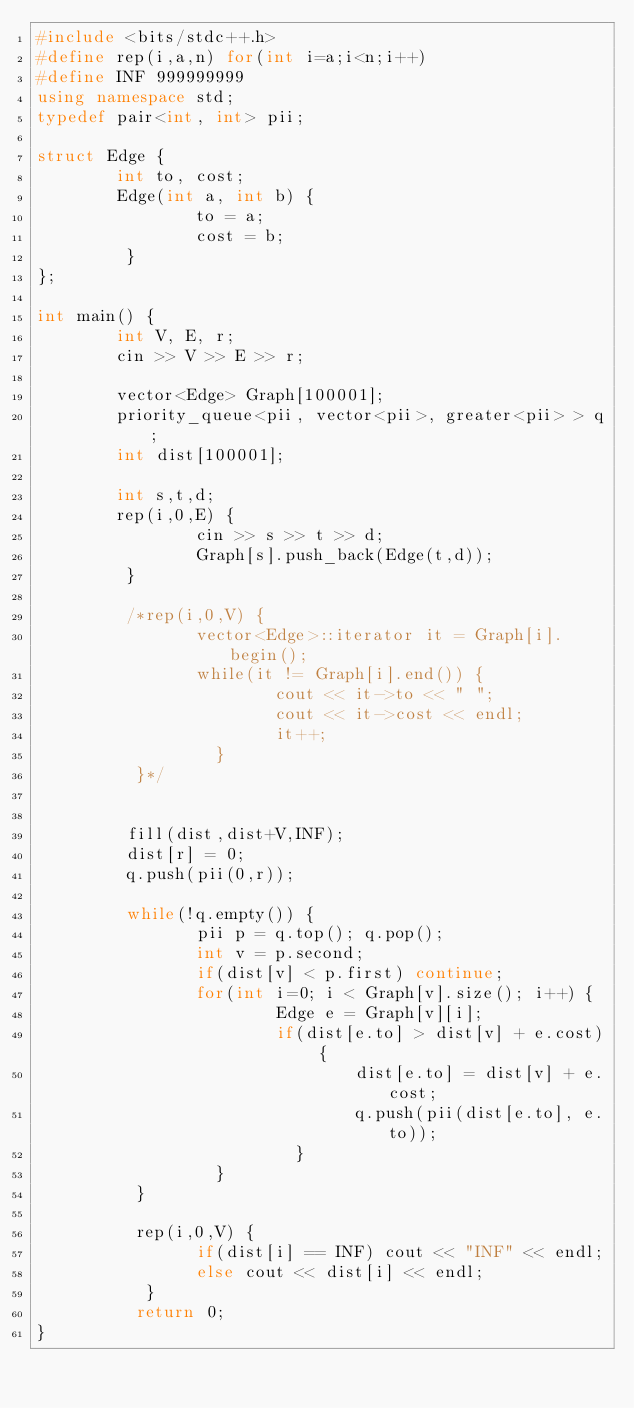Convert code to text. <code><loc_0><loc_0><loc_500><loc_500><_C++_>#include <bits/stdc++.h>
#define rep(i,a,n) for(int i=a;i<n;i++)
#define INF 999999999
using namespace std;
typedef pair<int, int> pii;

struct Edge {
        int to, cost;
        Edge(int a, int b) {
                to = a;
                cost = b;
         }
};

int main() {
        int V, E, r;
        cin >> V >> E >> r;
        
        vector<Edge> Graph[100001];
        priority_queue<pii, vector<pii>, greater<pii> > q; 
        int dist[100001];
        
        int s,t,d;
        rep(i,0,E) {
                cin >> s >> t >> d;       
                Graph[s].push_back(Edge(t,d));
         }
         
         /*rep(i,0,V) {
                vector<Edge>::iterator it = Graph[i].begin();
                while(it != Graph[i].end()) {
                        cout << it->to << " ";
                        cout << it->cost << endl;
                        it++;
                  }
          }*/
                        
         
         fill(dist,dist+V,INF);
         dist[r] = 0;
         q.push(pii(0,r));
         
         while(!q.empty()) {
                pii p = q.top(); q.pop();
                int v = p.second;
                if(dist[v] < p.first) continue;
                for(int i=0; i < Graph[v].size(); i++) {
                        Edge e = Graph[v][i];
                        if(dist[e.to] > dist[v] + e.cost) {
                                dist[e.to] = dist[v] + e.cost;
                                q.push(pii(dist[e.to], e.to));
                          }
                  }
          }
          
          rep(i,0,V) {
                if(dist[i] == INF) cout << "INF" << endl;
                else cout << dist[i] << endl;
           }
          return 0;
}</code> 